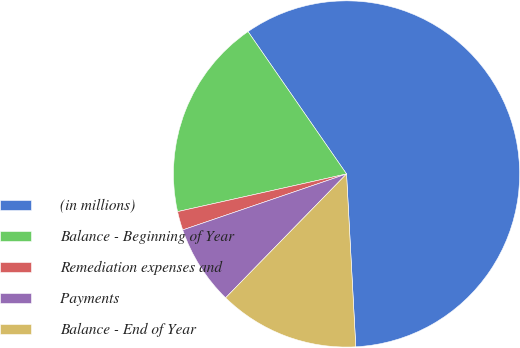Convert chart. <chart><loc_0><loc_0><loc_500><loc_500><pie_chart><fcel>(in millions)<fcel>Balance - Beginning of Year<fcel>Remediation expenses and<fcel>Payments<fcel>Balance - End of Year<nl><fcel>58.78%<fcel>18.86%<fcel>1.75%<fcel>7.45%<fcel>13.16%<nl></chart> 